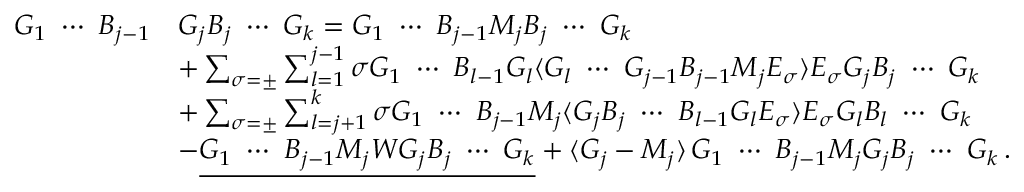<formula> <loc_0><loc_0><loc_500><loc_500>\begin{array} { r l } { G _ { 1 } \ \cdots \ B _ { j - 1 } } & { G _ { j } B _ { j } \ \cdots \ G _ { k } = G _ { 1 } \ \cdots \ B _ { j - 1 } M _ { j } B _ { j } \ \cdots \ G _ { k } } \\ & { + \sum _ { \sigma = \pm } \sum _ { l = 1 } ^ { j - 1 } \sigma G _ { 1 } \ \cdots \ B _ { l - 1 } G _ { l } \langle G _ { l } \ \cdots \ G _ { j - 1 } B _ { j - 1 } M _ { j } E _ { \sigma } \rangle E _ { \sigma } G _ { j } B _ { j } \ \cdots \ G _ { k } } \\ & { + \sum _ { \sigma = \pm } \sum _ { l = j + 1 } ^ { k } \sigma G _ { 1 } \ \cdots \ B _ { j - 1 } M _ { j } \langle G _ { j } B _ { j } \ \cdots \ B _ { l - 1 } G _ { l } E _ { \sigma } \rangle E _ { \sigma } G _ { l } B _ { l } \ \cdots \ G _ { k } } \\ & { - \underline { { G _ { 1 } \ \cdots \ B _ { j - 1 } M _ { j } W G _ { j } B _ { j } \ \cdots \ G _ { k } } } + \langle G _ { j } - M _ { j } \rangle \, G _ { 1 } \ \cdots \ B _ { j - 1 } M _ { j } G _ { j } B _ { j } \ \cdots \ G _ { k } \, . } \end{array}</formula> 